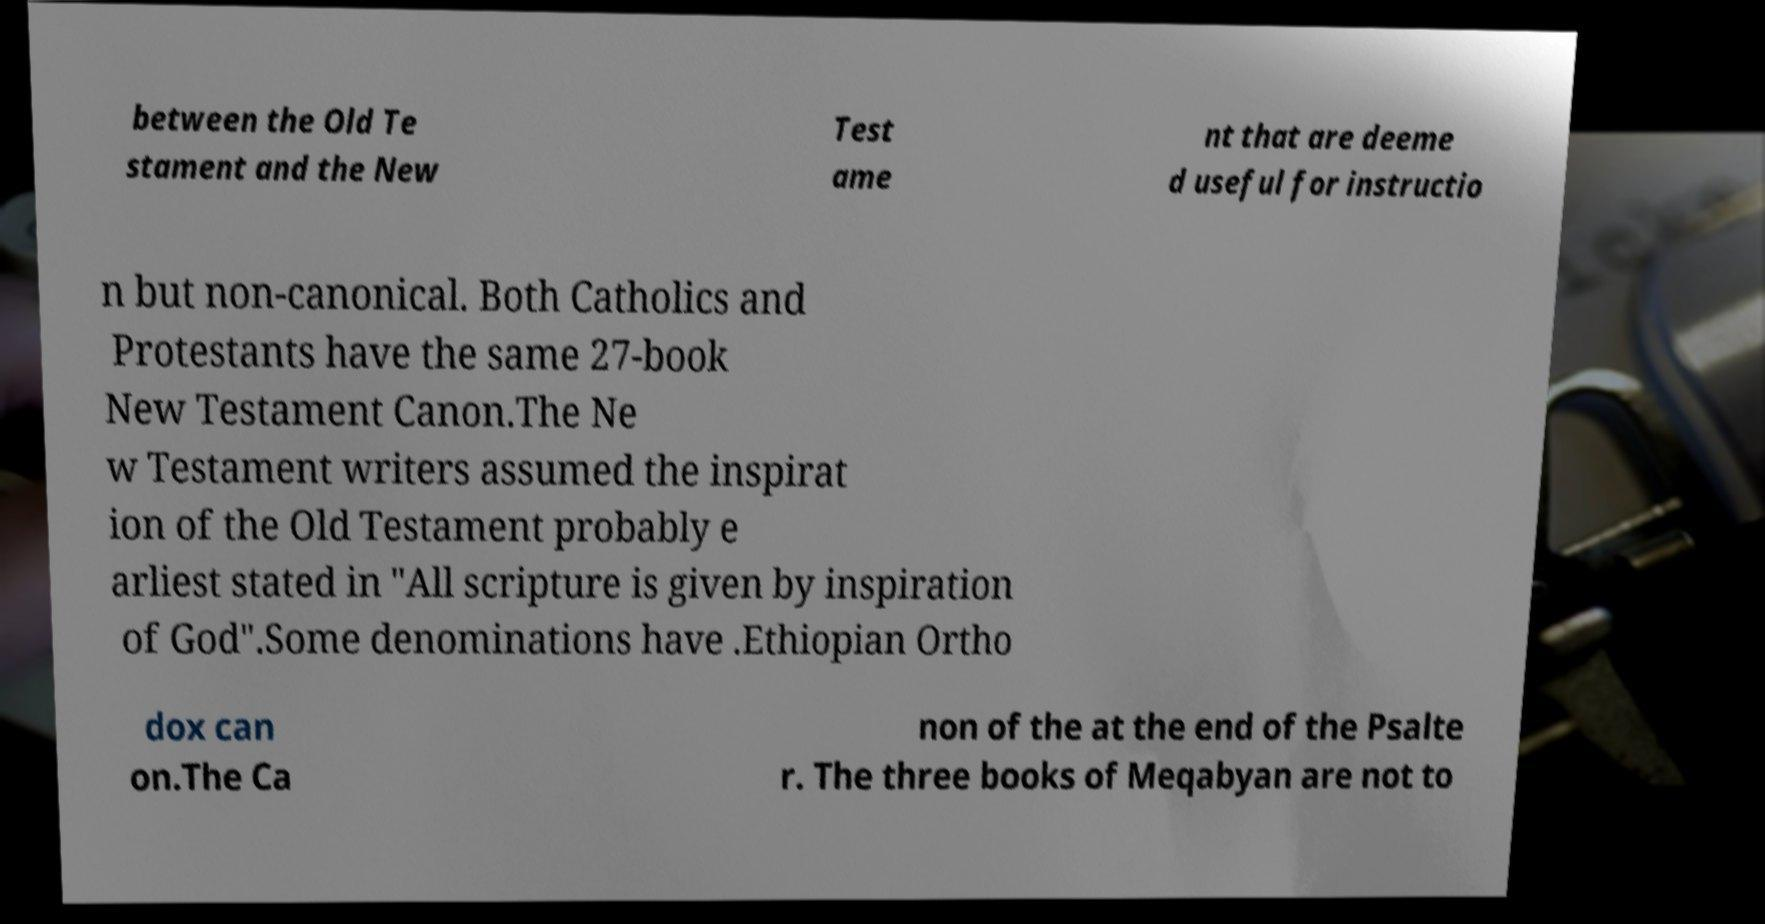Please read and relay the text visible in this image. What does it say? between the Old Te stament and the New Test ame nt that are deeme d useful for instructio n but non-canonical. Both Catholics and Protestants have the same 27-book New Testament Canon.The Ne w Testament writers assumed the inspirat ion of the Old Testament probably e arliest stated in "All scripture is given by inspiration of God".Some denominations have .Ethiopian Ortho dox can on.The Ca non of the at the end of the Psalte r. The three books of Meqabyan are not to 